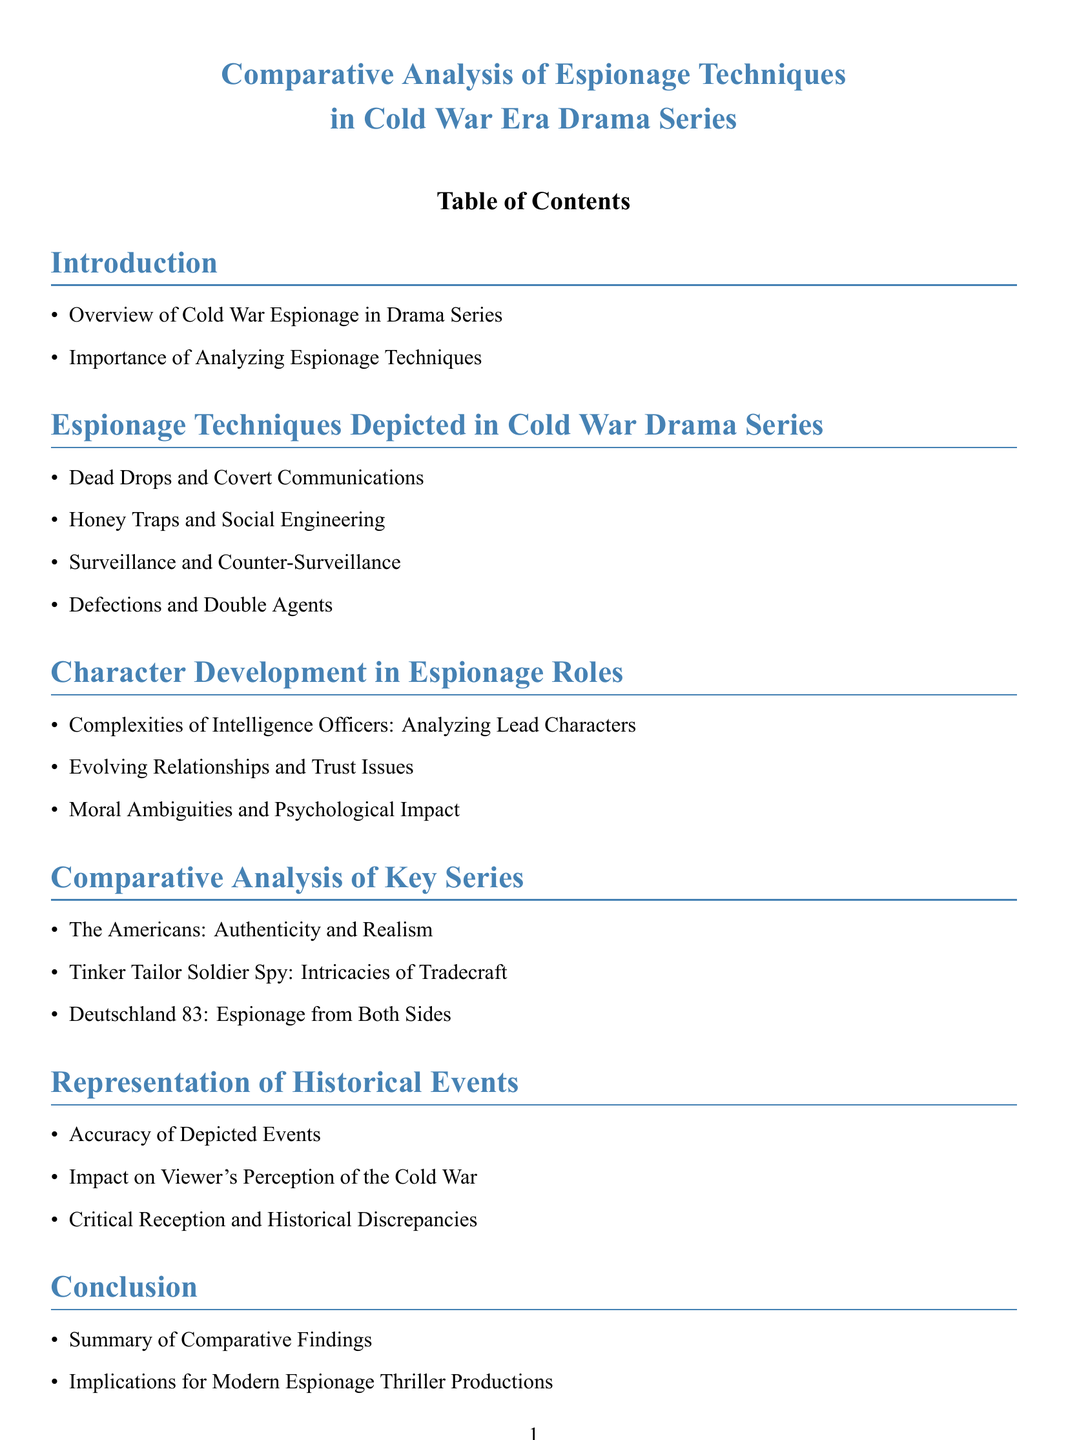What are the two main topics in the introduction? The introduction lists two topics: Overview of Cold War Espionage in Drama Series and Importance of Analyzing Espionage Techniques.
Answer: Overview of Cold War Espionage in Drama Series, Importance of Analyzing Espionage Techniques What is one espionage technique mentioned related to social manipulation? The document lists Honey Traps and Social Engineering as an espionage technique.
Answer: Honey Traps and Social Engineering How many subsections are there in the section on Character Development? The section on Character Development includes three subsections: Complexities of Intelligence Officers, Evolving Relationships, and Moral Ambiguities.
Answer: Three Which series is noted for its authenticity and realism? In the Comparative Analysis section, The Americans is noted for its authenticity and realism.
Answer: The Americans What does the conclusion summarize? The conclusion summarizes the Comparative Findings and their implications for modern productions.
Answer: Comparative Findings What type of sources are listed in the References section? The References section lists Primary Sources and Secondary Sources.
Answer: Primary Sources, Secondary Sources 